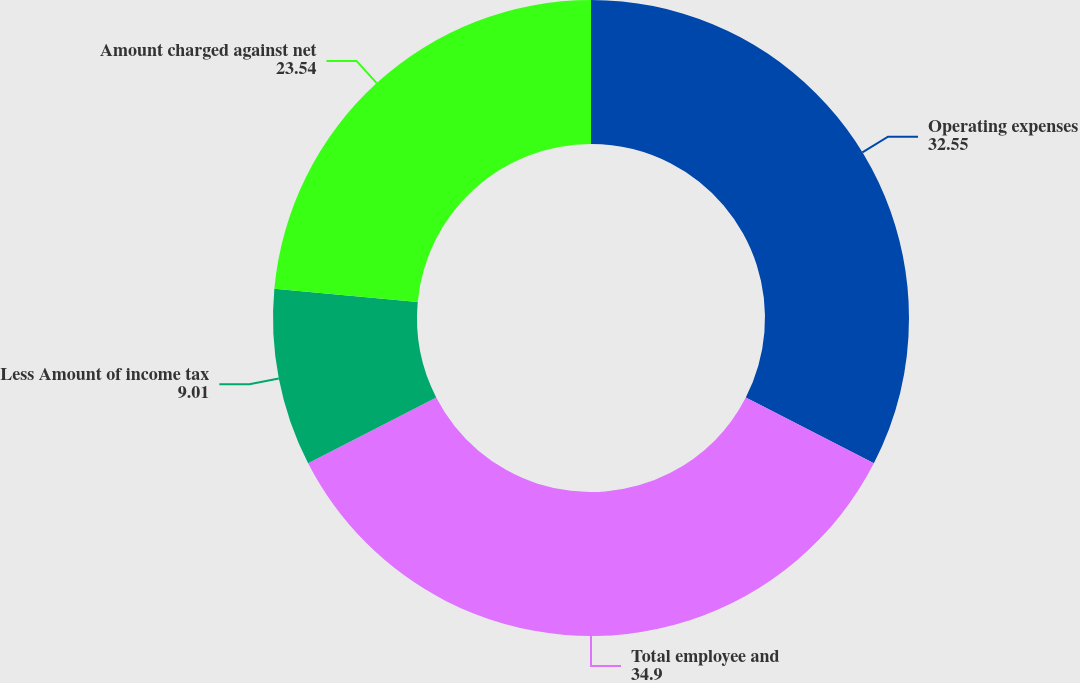Convert chart. <chart><loc_0><loc_0><loc_500><loc_500><pie_chart><fcel>Operating expenses<fcel>Total employee and<fcel>Less Amount of income tax<fcel>Amount charged against net<nl><fcel>32.55%<fcel>34.9%<fcel>9.01%<fcel>23.54%<nl></chart> 